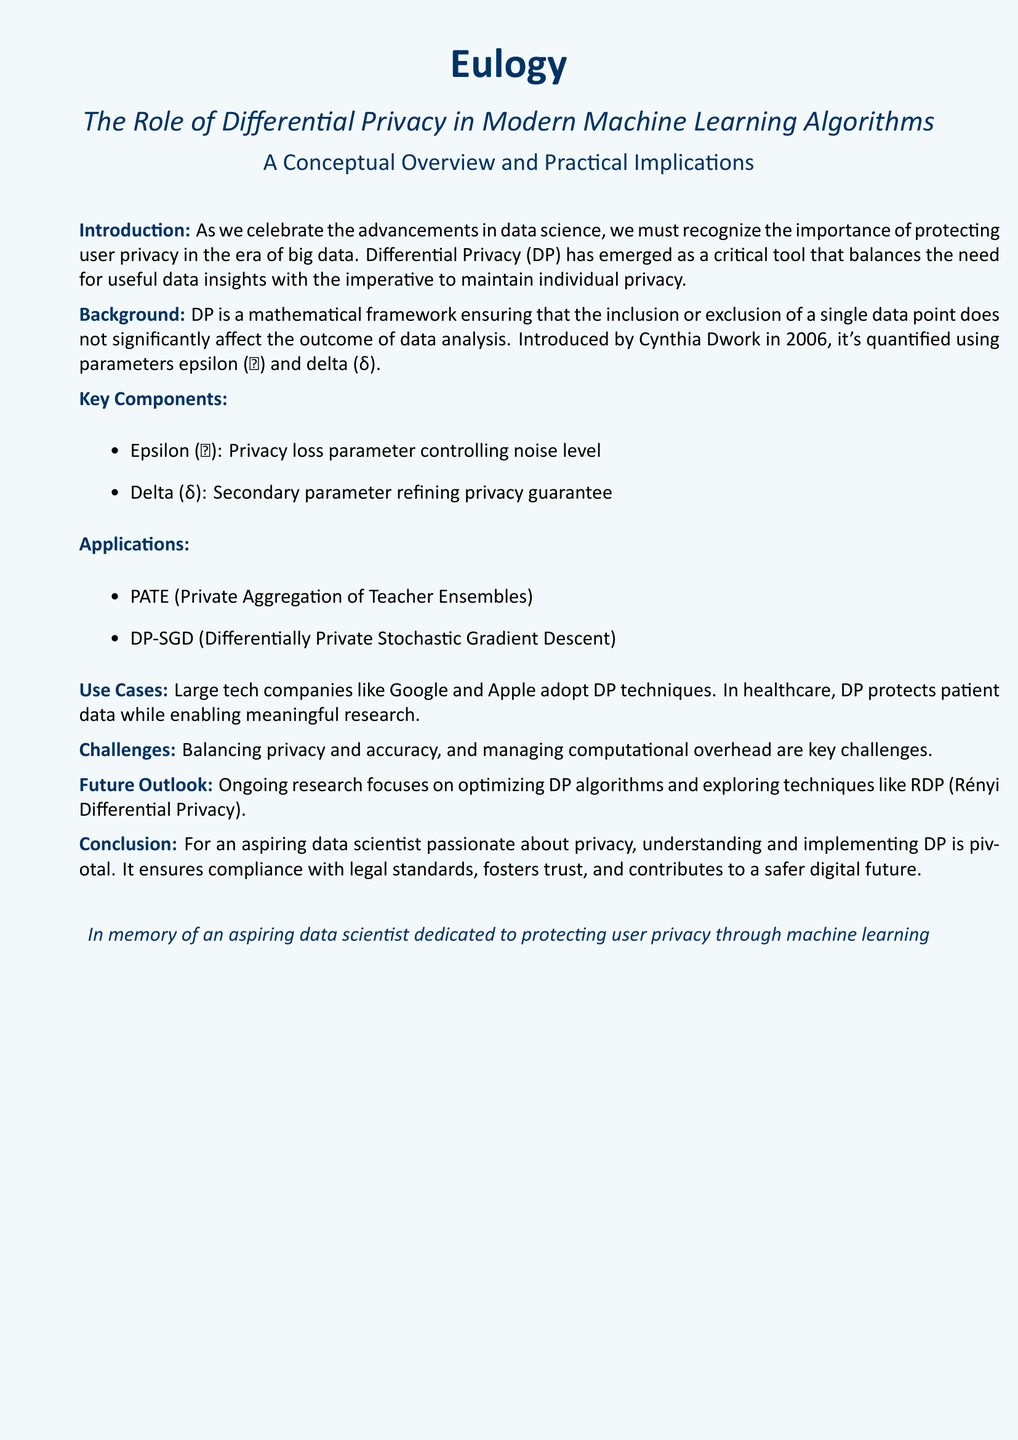What is the main topic of the eulogy? The eulogy focuses on the role of Differential Privacy in machine learning.
Answer: The Role of Differential Privacy in Modern Machine Learning Algorithms Who introduced Differential Privacy? The eulogy mentions Cynthia Dwork as the introduction of Differential Privacy.
Answer: Cynthia Dwork What is the privacy loss parameter referred to in the document? The document describes epsilon (ɛ) as the privacy loss parameter.
Answer: epsilon (ɛ) What are the applications of Differential Privacy mentioned? The document lists PATE and DP-SGD as applications of Differential Privacy.
Answer: PATE, DP-SGD What is one of the challenges in implementing Differential Privacy? The document highlights balancing privacy and accuracy as a challenge.
Answer: Balancing privacy and accuracy What future technique is being explored in relation to Differential Privacy? The eulogy notes that RDP is a future technique related to Differential Privacy.
Answer: RDP (Rényi Differential Privacy) What is the significance of understanding Differential Privacy for an aspiring data scientist? The document emphasizes that understanding DP ensures compliance and fosters trust.
Answer: Compliance and trust What year was Differential Privacy introduced? The document states that Differential Privacy was introduced in 2006.
Answer: 2006 